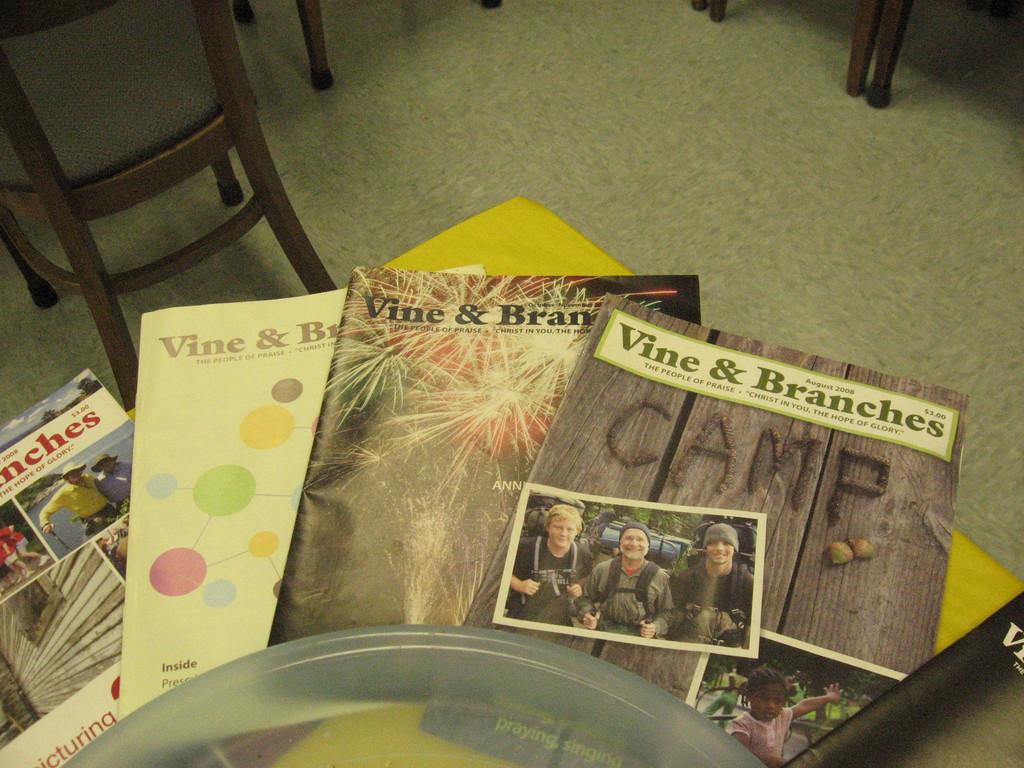<image>
Write a terse but informative summary of the picture. Vine and branches Camp magazines for August 2008. 